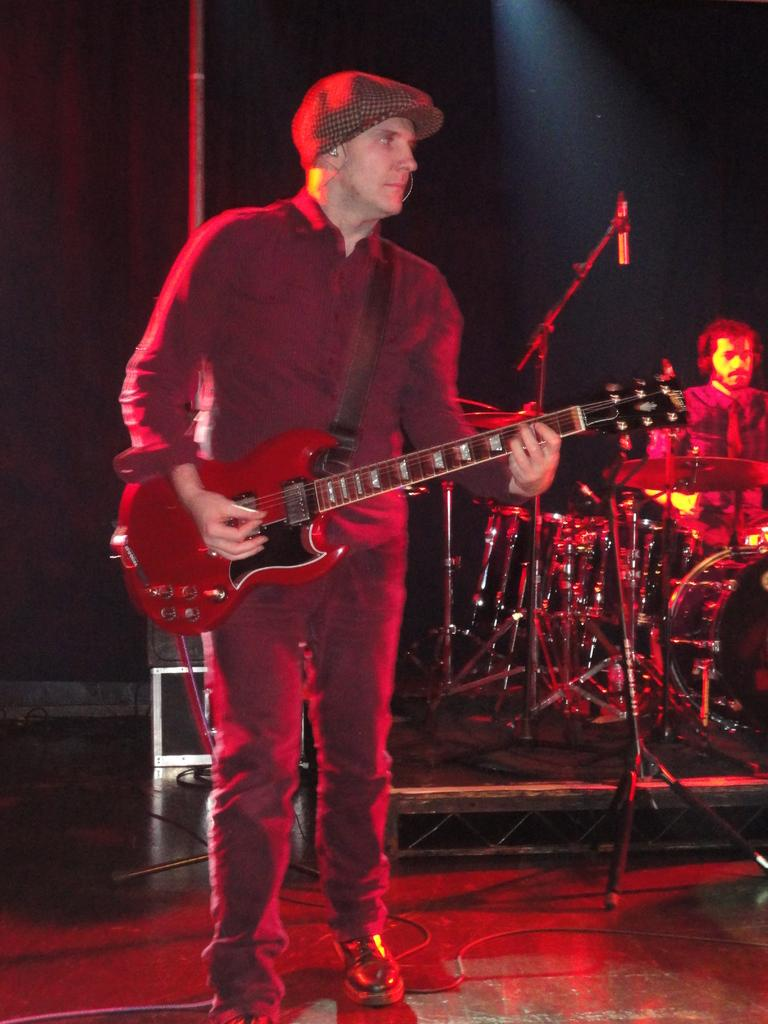What is the main activity of the person in the image? The person in the image is playing a guitar. Can you describe the second person in the image? The second person in the image is playing drums. What type of instruments are being played in the image? The person is playing a guitar, and the second person is playing drums. How many spiders are crawling on the guitar in the image? There are no spiders present in the image; it features a person playing a guitar and another person playing drums. 